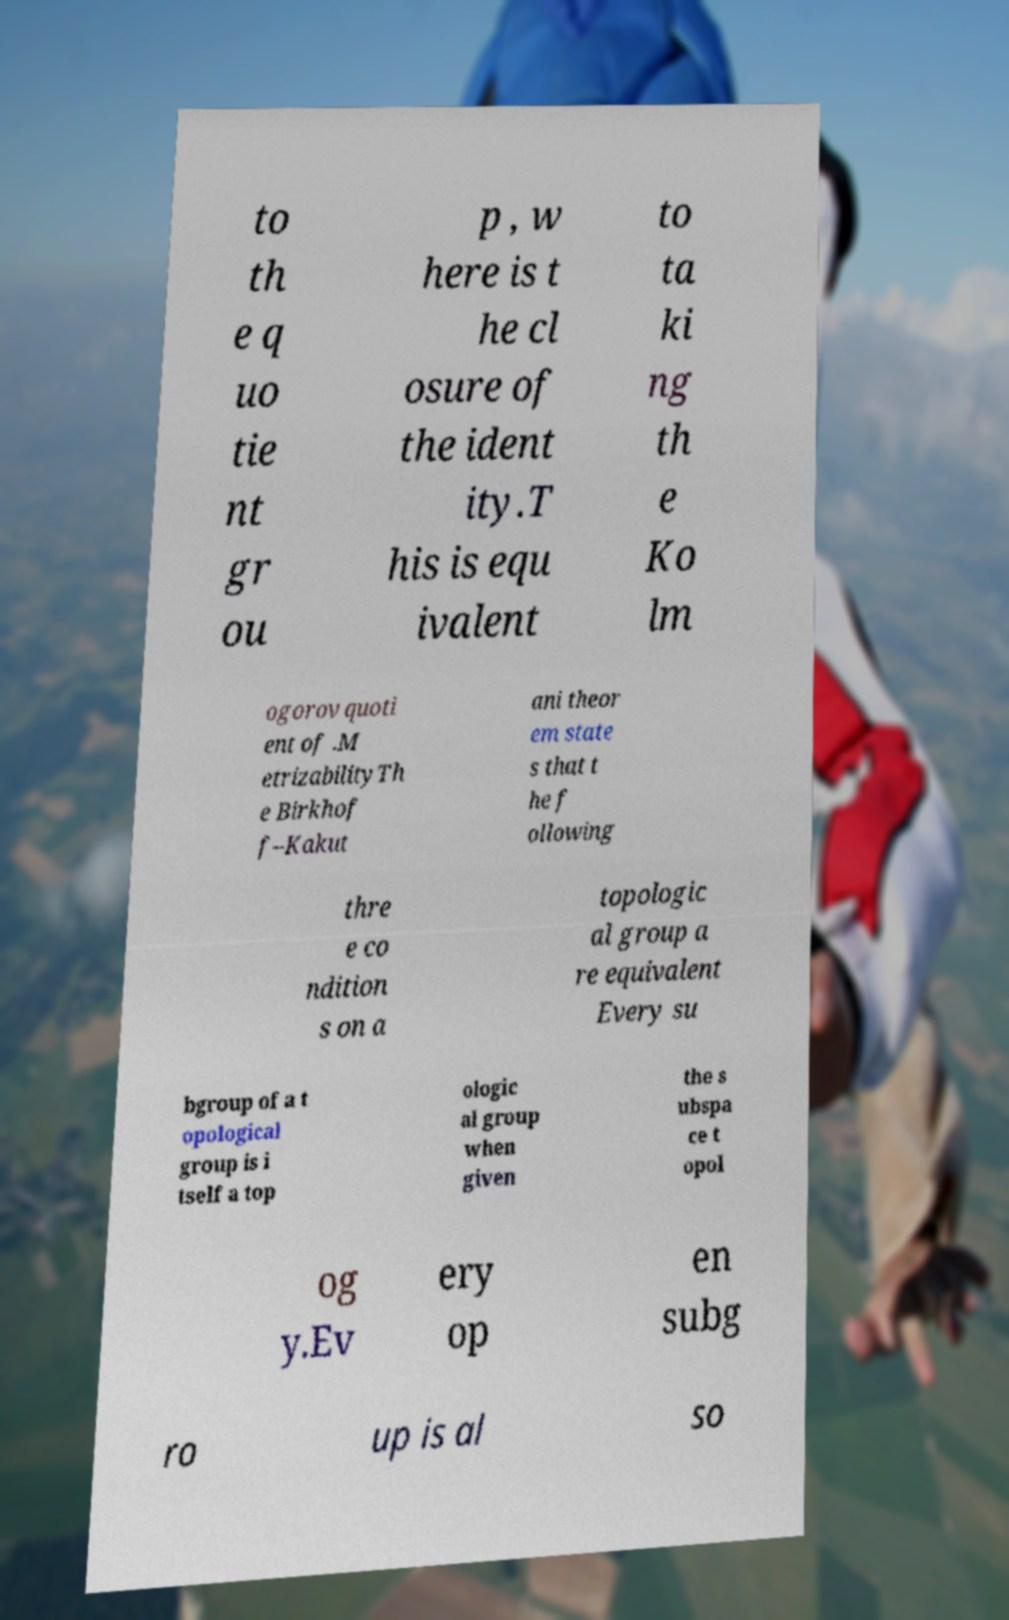For documentation purposes, I need the text within this image transcribed. Could you provide that? to th e q uo tie nt gr ou p , w here is t he cl osure of the ident ity.T his is equ ivalent to ta ki ng th e Ko lm ogorov quoti ent of .M etrizabilityTh e Birkhof f–Kakut ani theor em state s that t he f ollowing thre e co ndition s on a topologic al group a re equivalent Every su bgroup of a t opological group is i tself a top ologic al group when given the s ubspa ce t opol og y.Ev ery op en subg ro up is al so 